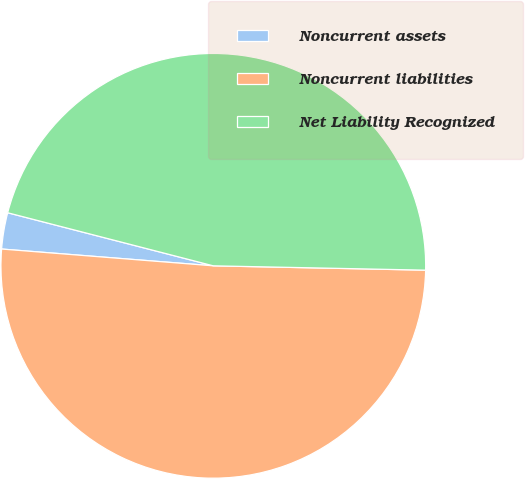<chart> <loc_0><loc_0><loc_500><loc_500><pie_chart><fcel>Noncurrent assets<fcel>Noncurrent liabilities<fcel>Net Liability Recognized<nl><fcel>2.76%<fcel>50.94%<fcel>46.31%<nl></chart> 